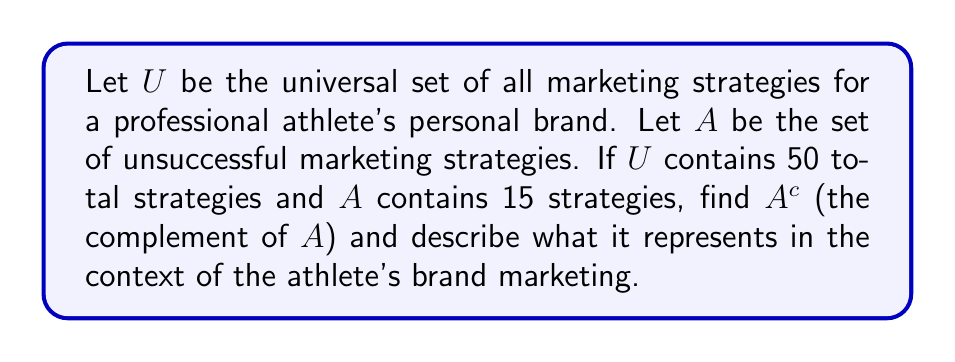Provide a solution to this math problem. To solve this problem, we need to understand the concept of set complement and apply it to the given scenario:

1) The complement of a set $A$, denoted as $A^c$, consists of all elements in the universal set $U$ that are not in $A$.

2) Mathematically, we can express this as:
   $A^c = U - A$

3) We're given that:
   $|U| = 50$ (total number of marketing strategies)
   $|A| = 15$ (number of unsuccessful strategies)

4) To find $|A^c|$, we subtract $|A|$ from $|U|$:
   $|A^c| = |U| - |A| = 50 - 15 = 35$

5) In the context of the athlete's brand marketing:
   - $A$ represents unsuccessful marketing strategies
   - $A^c$ represents all strategies that are not unsuccessful, which we can interpret as successful or potentially successful strategies

6) Therefore, $A^c$ contains 35 marketing strategies that are either proven to be successful or have the potential to be successful for the athlete's personal brand.

This information is crucial for the athlete's media endeavors, as it helps focus efforts on strategies more likely to yield positive results for their personal brand.
Answer: $A^c$ contains 35 elements, representing the successful or potentially successful marketing strategies for the athlete's personal brand. 